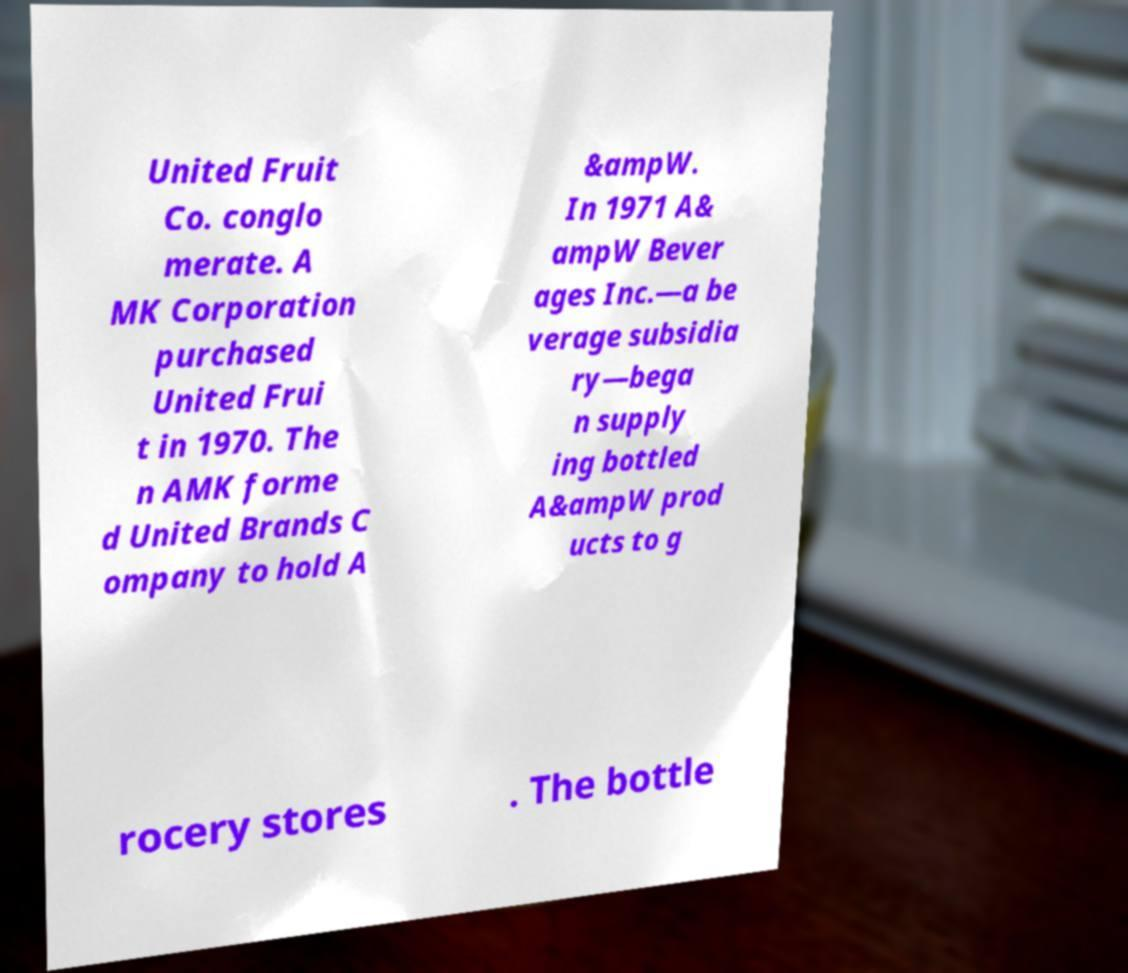Can you read and provide the text displayed in the image?This photo seems to have some interesting text. Can you extract and type it out for me? United Fruit Co. conglo merate. A MK Corporation purchased United Frui t in 1970. The n AMK forme d United Brands C ompany to hold A &ampW. In 1971 A& ampW Bever ages Inc.—a be verage subsidia ry—bega n supply ing bottled A&ampW prod ucts to g rocery stores . The bottle 